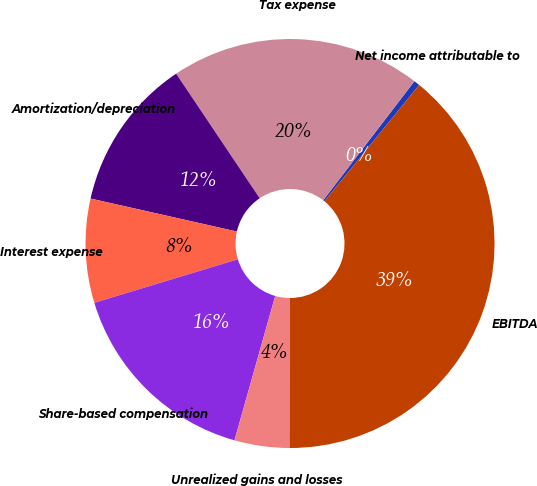Convert chart to OTSL. <chart><loc_0><loc_0><loc_500><loc_500><pie_chart><fcel>Net income attributable to<fcel>Tax expense<fcel>Amortization/depreciation<fcel>Interest expense<fcel>Share-based compensation<fcel>Unrealized gains and losses<fcel>EBITDA<nl><fcel>0.47%<fcel>19.81%<fcel>12.07%<fcel>8.21%<fcel>15.94%<fcel>4.34%<fcel>39.16%<nl></chart> 